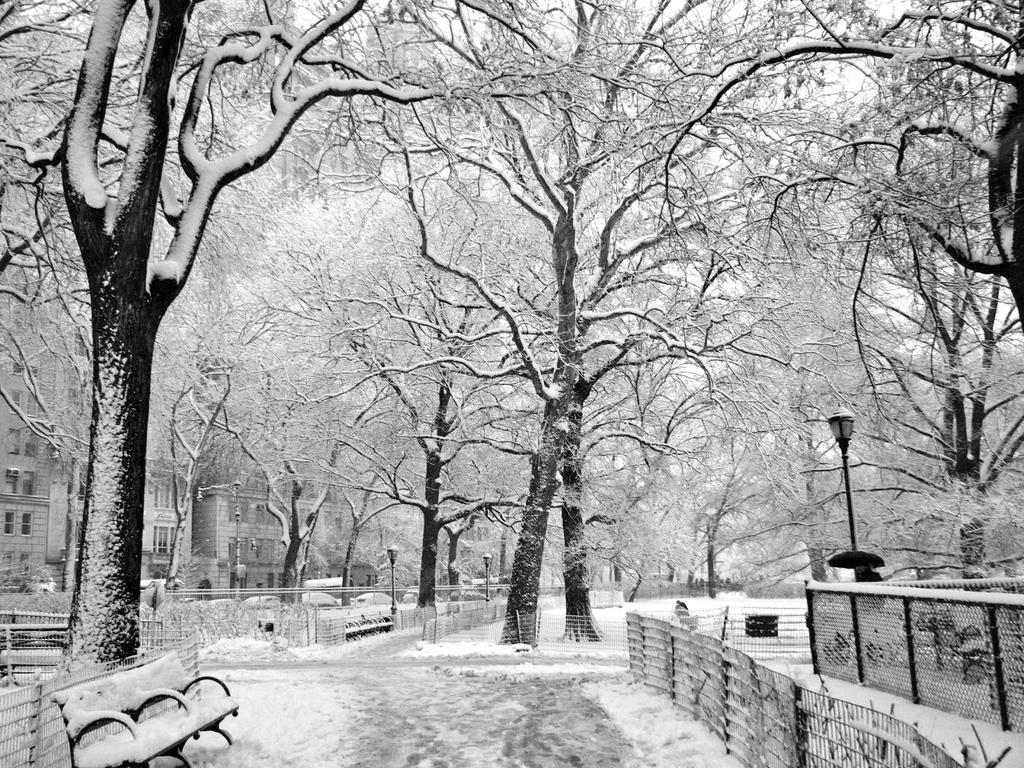What is the color scheme of the image? The image is black and white. What can be seen in the middle of the image? There are trees in the middle of the image. What is located at the bottom of the image? There is a bench at the bottom of the image. What type of structures are on the left side of the image? There are buildings on the left side of the image. What is the texture or appearance of the ice in the image? There is ice visible in the image. What type of note is attached to the tree in the image? There is no note attached to the tree in the image, as it is a black and white image with no visible text or objects other than those mentioned in the facts. 